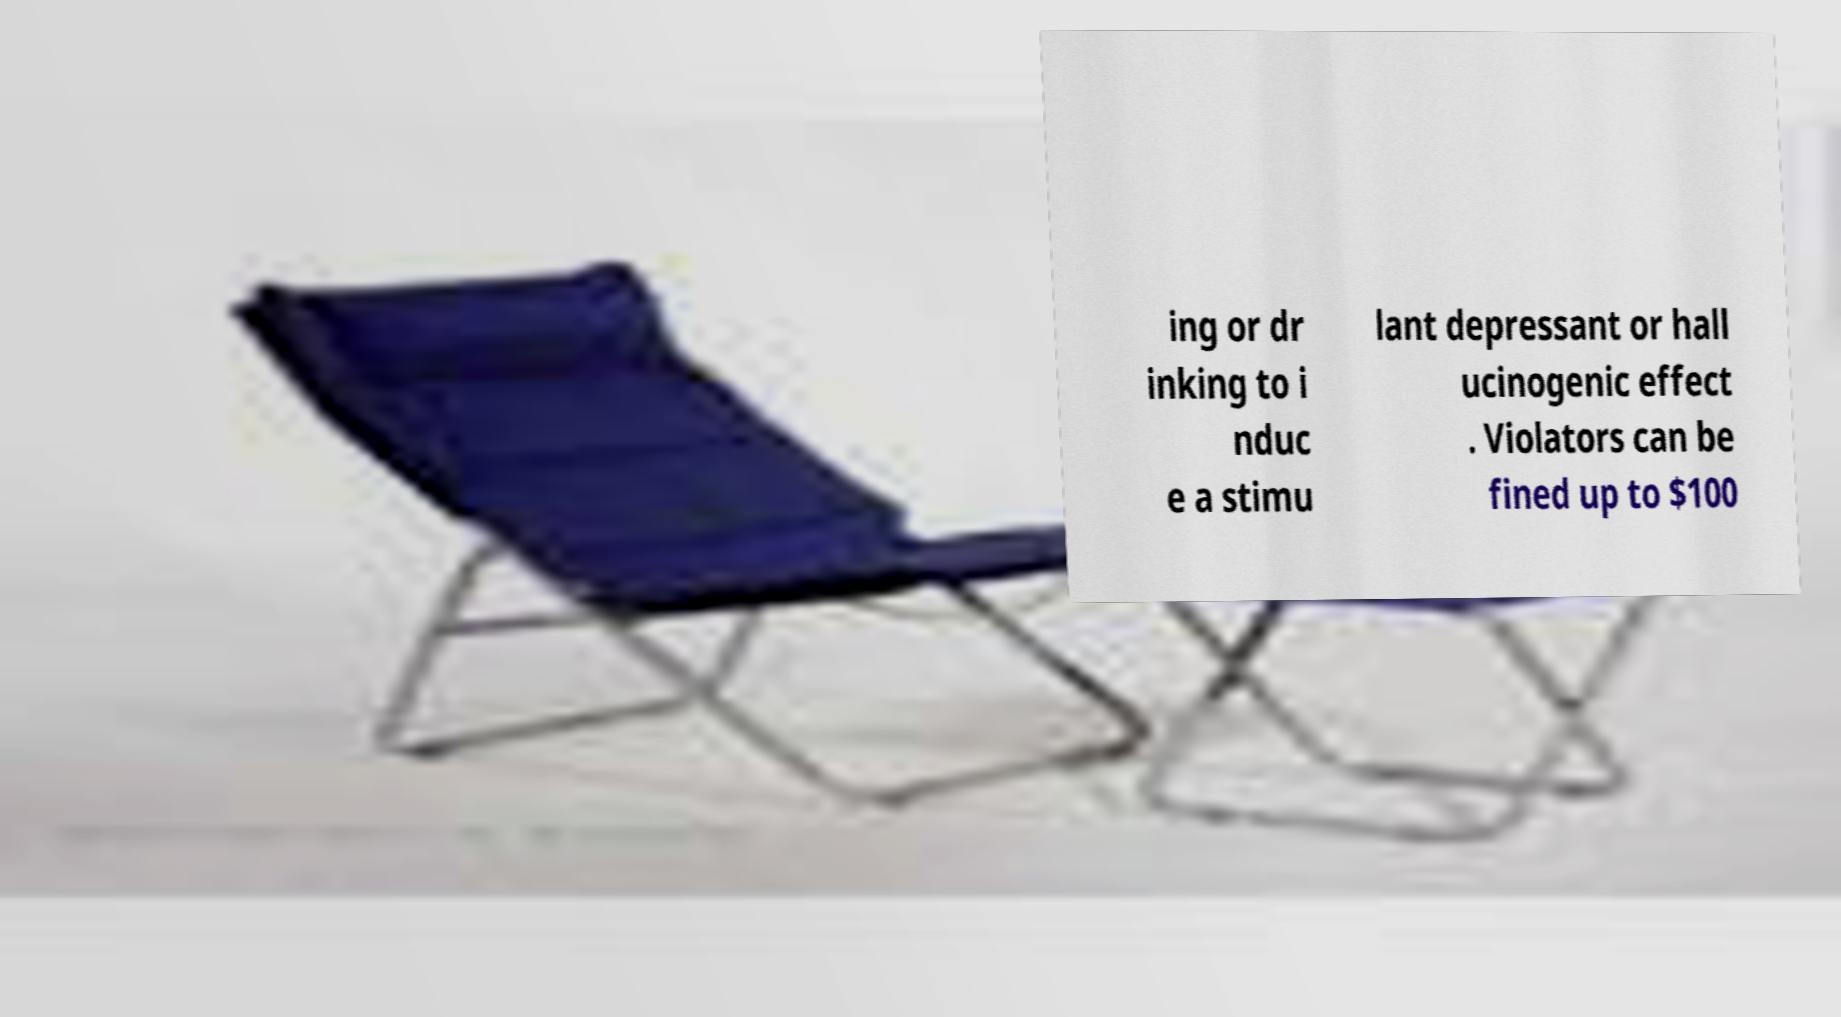There's text embedded in this image that I need extracted. Can you transcribe it verbatim? ing or dr inking to i nduc e a stimu lant depressant or hall ucinogenic effect . Violators can be fined up to $100 